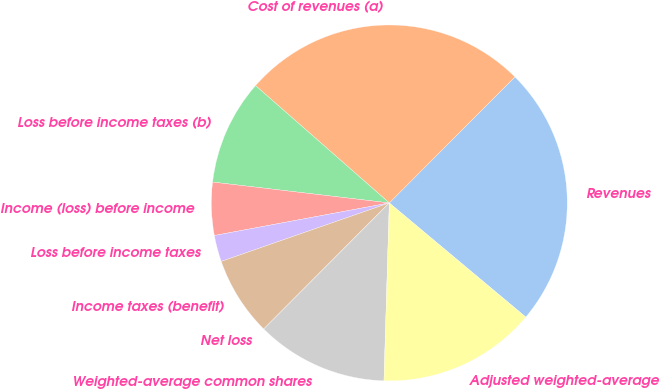<chart> <loc_0><loc_0><loc_500><loc_500><pie_chart><fcel>Revenues<fcel>Cost of revenues (a)<fcel>Loss before income taxes (b)<fcel>Income (loss) before income<fcel>Loss before income taxes<fcel>Income taxes (benefit)<fcel>Net loss<fcel>Weighted-average common shares<fcel>Adjusted weighted-average<nl><fcel>23.61%<fcel>26.01%<fcel>9.59%<fcel>4.8%<fcel>2.4%<fcel>7.2%<fcel>0.0%<fcel>11.99%<fcel>14.39%<nl></chart> 